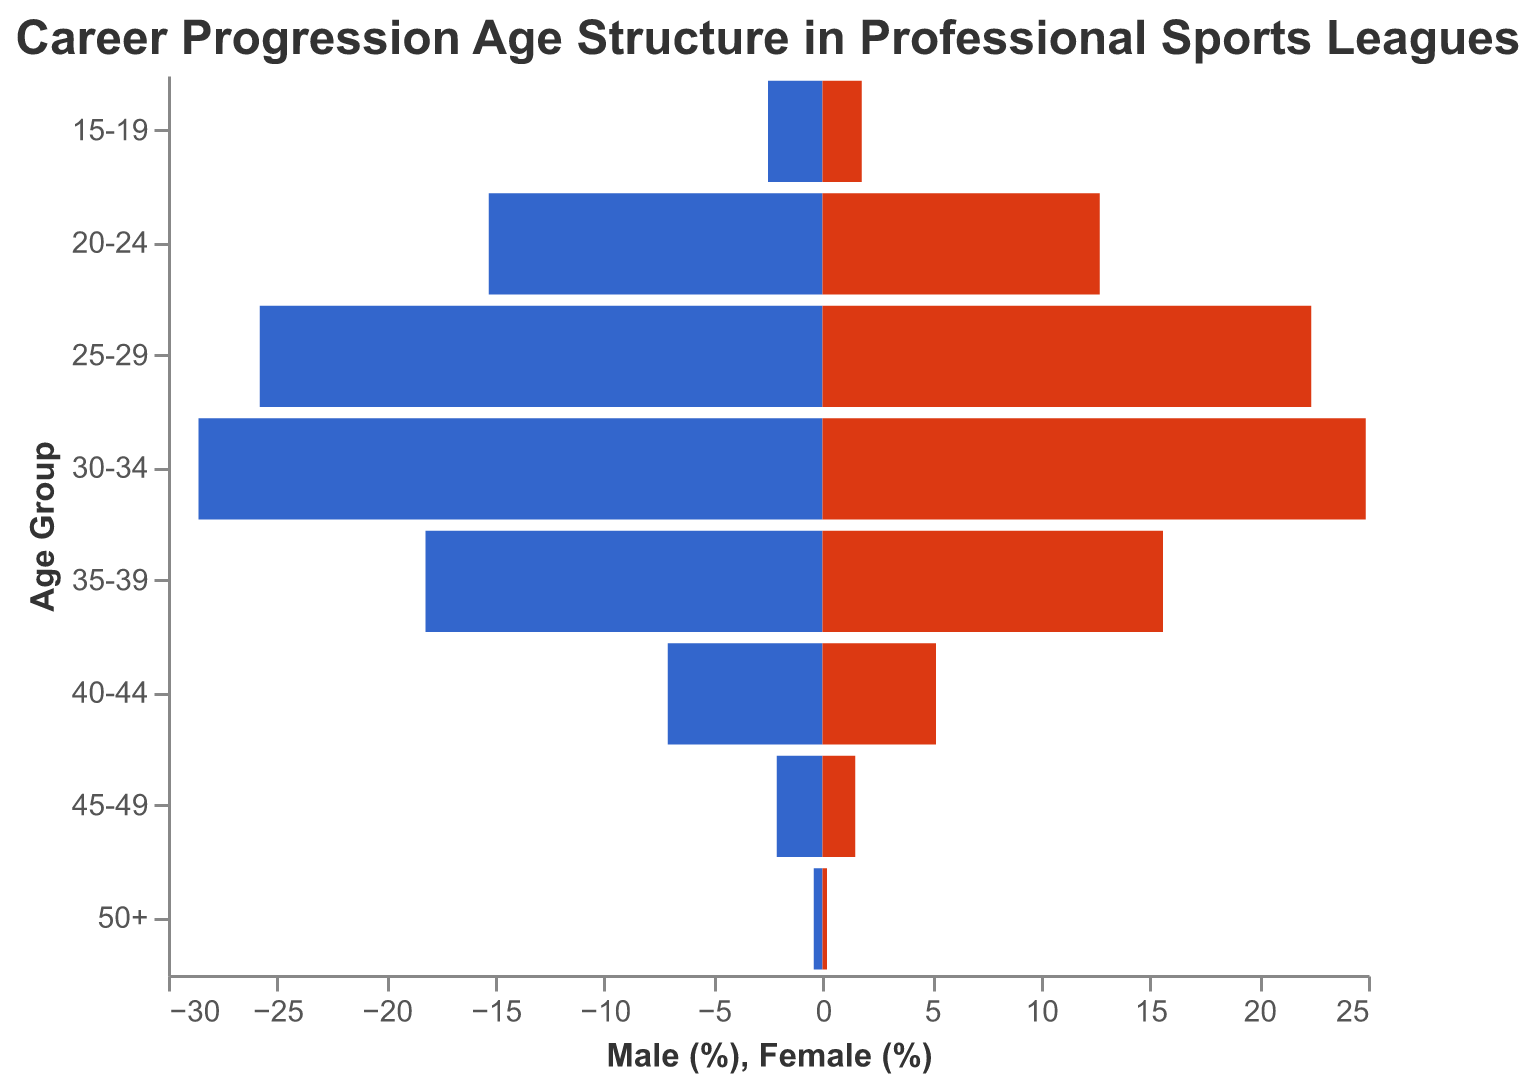What's the title of the figure? The title can be identified at the top of the figure, which provides context about the data being visualized.
Answer: Career Progression Age Structure in Professional Sports Leagues Which age group has the highest percentage of female athletes? Look at the bars representing female athletes and compare their lengths to determine which is the longest.
Answer: 30-34 How does the percentage of male athletes in the 25-29 age group compare to the percentage of female athletes in the same age group? Subtract the percentage of female athletes from the percentage of male athletes within the 25-29 age group.
Answer: 3.4% What is the total combined percentage of male and female athletes in the 20-24 age group? Add the percentages of both male and female athletes in the 20-24 age group.
Answer: 28.0% Which gender generally has a higher percentage across all age groups? Compare the percentages of males and females within each age group and determine which gender has higher values more frequently.
Answer: Male By how much does the percentage of male athletes in the 30-34 age group exceed the percentage of male athletes in the 35-39 age group? Subtract the percentage of male athletes in the 35-39 age group from the percentage in the 30-34 age group.
Answer: 10.4% In which age group is the difference between male and female athletes the smallest? Calculate the absolute differences between male and female percentages across age groups and find the smallest difference.
Answer: 15-19 Which age group has the smallest representation of male athletes? Identify the age group with the shortest bar representing male athletes.
Answer: 50+ What pattern do you notice in the distribution of male and female athletes across age groups? Observe the changes in the lengths of bars for both genders across age groups to identify any patterns (e.g., increases, peaks, decreases).
Answer: Peaks at 30-34, decreasing towards younger and older age groups Is there any age group where the percentage of female athletes is higher than that of male athletes? Compare the lengths of the bars for both genders in each age group to check for any instances where the female bar is longer than the male bar.
Answer: No 